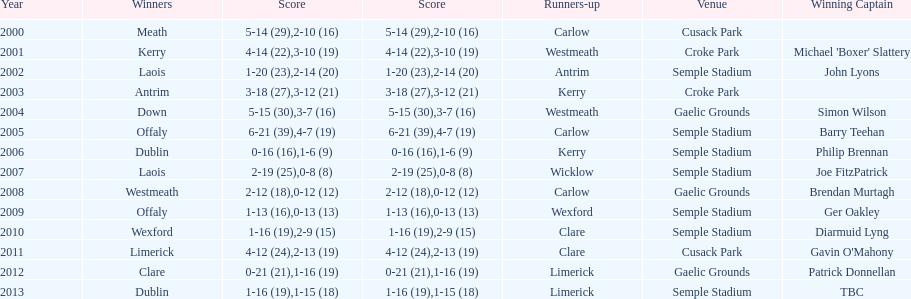Who held the title of the first successful captain? Michael 'Boxer' Slattery. 